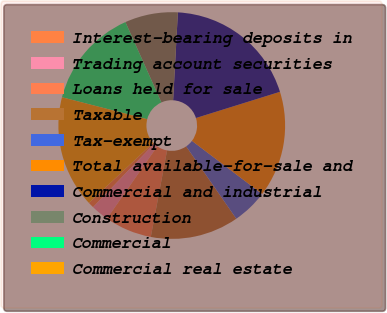Convert chart to OTSL. <chart><loc_0><loc_0><loc_500><loc_500><pie_chart><fcel>Interest-bearing deposits in<fcel>Trading account securities<fcel>Loans held for sale<fcel>Taxable<fcel>Tax-exempt<fcel>Total available-for-sale and<fcel>Commercial and industrial<fcel>Construction<fcel>Commercial<fcel>Commercial real estate<nl><fcel>0.84%<fcel>2.52%<fcel>6.72%<fcel>12.6%<fcel>5.04%<fcel>15.12%<fcel>19.32%<fcel>7.56%<fcel>14.28%<fcel>15.96%<nl></chart> 